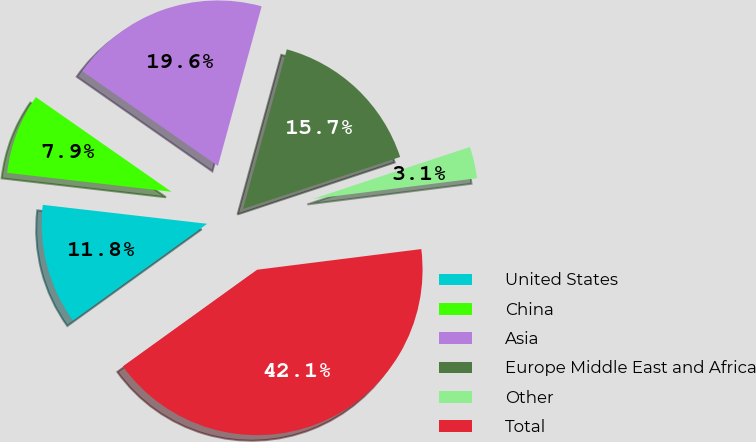Convert chart to OTSL. <chart><loc_0><loc_0><loc_500><loc_500><pie_chart><fcel>United States<fcel>China<fcel>Asia<fcel>Europe Middle East and Africa<fcel>Other<fcel>Total<nl><fcel>11.76%<fcel>7.87%<fcel>19.56%<fcel>15.66%<fcel>3.09%<fcel>42.06%<nl></chart> 